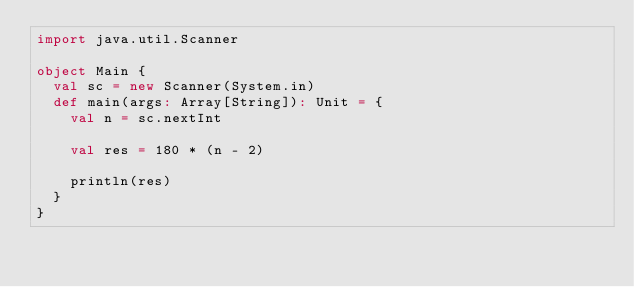<code> <loc_0><loc_0><loc_500><loc_500><_Scala_>import java.util.Scanner

object Main {
  val sc = new Scanner(System.in)
  def main(args: Array[String]): Unit = {
    val n = sc.nextInt

    val res = 180 * (n - 2)

    println(res)
  }
}
</code> 